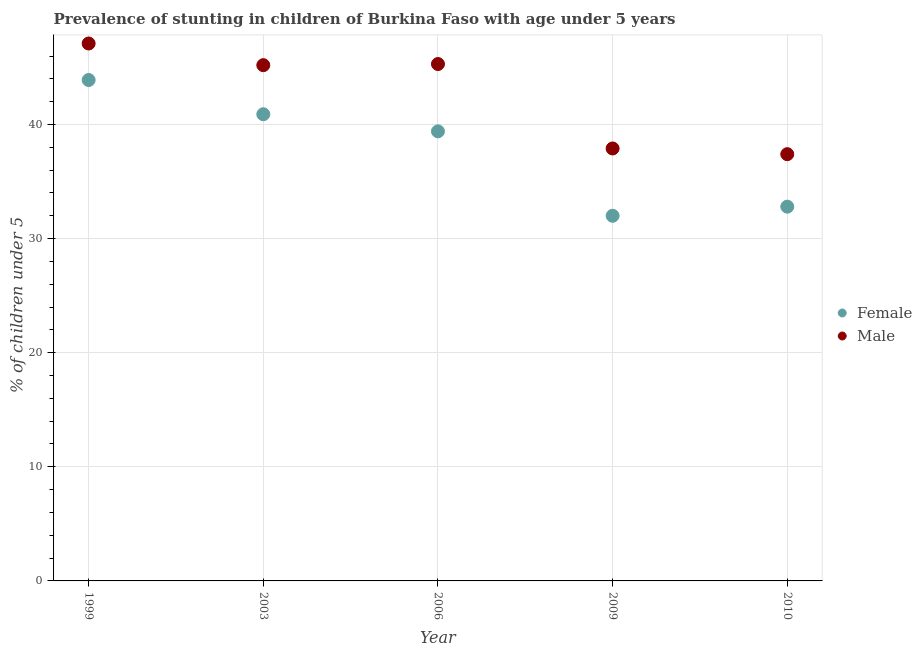How many different coloured dotlines are there?
Your response must be concise. 2. Is the number of dotlines equal to the number of legend labels?
Provide a short and direct response. Yes. What is the percentage of stunted male children in 1999?
Offer a very short reply. 47.1. Across all years, what is the maximum percentage of stunted female children?
Provide a short and direct response. 43.9. In which year was the percentage of stunted male children maximum?
Your answer should be very brief. 1999. In which year was the percentage of stunted female children minimum?
Make the answer very short. 2009. What is the total percentage of stunted male children in the graph?
Your answer should be very brief. 212.9. What is the difference between the percentage of stunted female children in 1999 and that in 2009?
Provide a short and direct response. 11.9. What is the difference between the percentage of stunted male children in 2003 and the percentage of stunted female children in 2009?
Your response must be concise. 13.2. What is the average percentage of stunted male children per year?
Offer a terse response. 42.58. In the year 2003, what is the difference between the percentage of stunted female children and percentage of stunted male children?
Offer a very short reply. -4.3. In how many years, is the percentage of stunted female children greater than 28 %?
Keep it short and to the point. 5. What is the ratio of the percentage of stunted female children in 2006 to that in 2010?
Make the answer very short. 1.2. Is the percentage of stunted female children in 1999 less than that in 2010?
Give a very brief answer. No. Is the difference between the percentage of stunted female children in 1999 and 2010 greater than the difference between the percentage of stunted male children in 1999 and 2010?
Give a very brief answer. Yes. What is the difference between the highest and the second highest percentage of stunted female children?
Ensure brevity in your answer.  3. What is the difference between the highest and the lowest percentage of stunted male children?
Your answer should be compact. 9.7. Does the percentage of stunted male children monotonically increase over the years?
Ensure brevity in your answer.  No. Is the percentage of stunted female children strictly greater than the percentage of stunted male children over the years?
Keep it short and to the point. No. How many dotlines are there?
Your response must be concise. 2. How many years are there in the graph?
Offer a very short reply. 5. Are the values on the major ticks of Y-axis written in scientific E-notation?
Provide a succinct answer. No. Does the graph contain any zero values?
Your answer should be compact. No. Where does the legend appear in the graph?
Your answer should be compact. Center right. How many legend labels are there?
Offer a very short reply. 2. What is the title of the graph?
Provide a succinct answer. Prevalence of stunting in children of Burkina Faso with age under 5 years. Does "Import" appear as one of the legend labels in the graph?
Your answer should be compact. No. What is the label or title of the Y-axis?
Offer a terse response.  % of children under 5. What is the  % of children under 5 in Female in 1999?
Make the answer very short. 43.9. What is the  % of children under 5 in Male in 1999?
Provide a short and direct response. 47.1. What is the  % of children under 5 in Female in 2003?
Provide a succinct answer. 40.9. What is the  % of children under 5 in Male in 2003?
Offer a very short reply. 45.2. What is the  % of children under 5 of Female in 2006?
Keep it short and to the point. 39.4. What is the  % of children under 5 in Male in 2006?
Your answer should be very brief. 45.3. What is the  % of children under 5 of Male in 2009?
Your answer should be compact. 37.9. What is the  % of children under 5 in Female in 2010?
Offer a terse response. 32.8. What is the  % of children under 5 of Male in 2010?
Your answer should be compact. 37.4. Across all years, what is the maximum  % of children under 5 of Female?
Offer a very short reply. 43.9. Across all years, what is the maximum  % of children under 5 of Male?
Offer a terse response. 47.1. Across all years, what is the minimum  % of children under 5 of Male?
Your response must be concise. 37.4. What is the total  % of children under 5 in Female in the graph?
Offer a very short reply. 189. What is the total  % of children under 5 of Male in the graph?
Offer a very short reply. 212.9. What is the difference between the  % of children under 5 in Male in 1999 and that in 2003?
Keep it short and to the point. 1.9. What is the difference between the  % of children under 5 of Male in 1999 and that in 2006?
Your response must be concise. 1.8. What is the difference between the  % of children under 5 of Female in 1999 and that in 2009?
Ensure brevity in your answer.  11.9. What is the difference between the  % of children under 5 of Female in 1999 and that in 2010?
Ensure brevity in your answer.  11.1. What is the difference between the  % of children under 5 in Male in 1999 and that in 2010?
Your response must be concise. 9.7. What is the difference between the  % of children under 5 in Female in 2003 and that in 2006?
Give a very brief answer. 1.5. What is the difference between the  % of children under 5 in Male in 2003 and that in 2009?
Offer a very short reply. 7.3. What is the difference between the  % of children under 5 in Male in 2003 and that in 2010?
Provide a short and direct response. 7.8. What is the difference between the  % of children under 5 of Female in 2006 and that in 2009?
Offer a very short reply. 7.4. What is the difference between the  % of children under 5 of Female in 2006 and that in 2010?
Provide a short and direct response. 6.6. What is the difference between the  % of children under 5 in Male in 2006 and that in 2010?
Provide a short and direct response. 7.9. What is the difference between the  % of children under 5 in Female in 2009 and that in 2010?
Give a very brief answer. -0.8. What is the difference between the  % of children under 5 in Female in 1999 and the  % of children under 5 in Male in 2003?
Ensure brevity in your answer.  -1.3. What is the difference between the  % of children under 5 of Female in 1999 and the  % of children under 5 of Male in 2006?
Offer a very short reply. -1.4. What is the difference between the  % of children under 5 of Female in 1999 and the  % of children under 5 of Male in 2009?
Ensure brevity in your answer.  6. What is the difference between the  % of children under 5 of Female in 2003 and the  % of children under 5 of Male in 2010?
Your response must be concise. 3.5. What is the difference between the  % of children under 5 of Female in 2009 and the  % of children under 5 of Male in 2010?
Your response must be concise. -5.4. What is the average  % of children under 5 in Female per year?
Provide a succinct answer. 37.8. What is the average  % of children under 5 in Male per year?
Give a very brief answer. 42.58. In the year 1999, what is the difference between the  % of children under 5 of Female and  % of children under 5 of Male?
Provide a succinct answer. -3.2. In the year 2003, what is the difference between the  % of children under 5 in Female and  % of children under 5 in Male?
Your answer should be compact. -4.3. What is the ratio of the  % of children under 5 of Female in 1999 to that in 2003?
Give a very brief answer. 1.07. What is the ratio of the  % of children under 5 in Male in 1999 to that in 2003?
Make the answer very short. 1.04. What is the ratio of the  % of children under 5 of Female in 1999 to that in 2006?
Provide a succinct answer. 1.11. What is the ratio of the  % of children under 5 in Male in 1999 to that in 2006?
Your answer should be compact. 1.04. What is the ratio of the  % of children under 5 of Female in 1999 to that in 2009?
Give a very brief answer. 1.37. What is the ratio of the  % of children under 5 in Male in 1999 to that in 2009?
Keep it short and to the point. 1.24. What is the ratio of the  % of children under 5 in Female in 1999 to that in 2010?
Your answer should be very brief. 1.34. What is the ratio of the  % of children under 5 in Male in 1999 to that in 2010?
Give a very brief answer. 1.26. What is the ratio of the  % of children under 5 in Female in 2003 to that in 2006?
Offer a terse response. 1.04. What is the ratio of the  % of children under 5 of Male in 2003 to that in 2006?
Your response must be concise. 1. What is the ratio of the  % of children under 5 of Female in 2003 to that in 2009?
Keep it short and to the point. 1.28. What is the ratio of the  % of children under 5 in Male in 2003 to that in 2009?
Your answer should be very brief. 1.19. What is the ratio of the  % of children under 5 in Female in 2003 to that in 2010?
Your answer should be very brief. 1.25. What is the ratio of the  % of children under 5 in Male in 2003 to that in 2010?
Offer a very short reply. 1.21. What is the ratio of the  % of children under 5 of Female in 2006 to that in 2009?
Keep it short and to the point. 1.23. What is the ratio of the  % of children under 5 in Male in 2006 to that in 2009?
Your answer should be compact. 1.2. What is the ratio of the  % of children under 5 in Female in 2006 to that in 2010?
Make the answer very short. 1.2. What is the ratio of the  % of children under 5 in Male in 2006 to that in 2010?
Ensure brevity in your answer.  1.21. What is the ratio of the  % of children under 5 in Female in 2009 to that in 2010?
Make the answer very short. 0.98. What is the ratio of the  % of children under 5 in Male in 2009 to that in 2010?
Offer a very short reply. 1.01. 